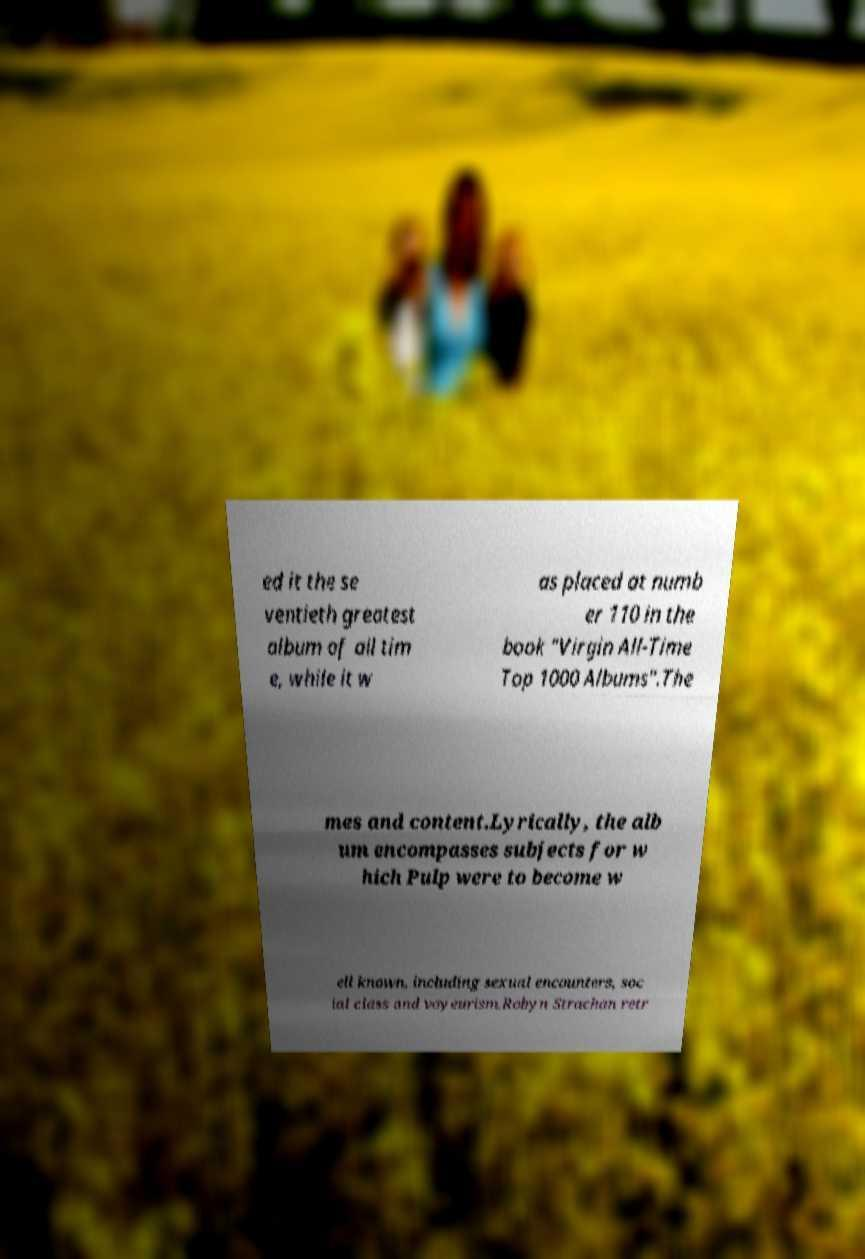What messages or text are displayed in this image? I need them in a readable, typed format. ed it the se ventieth greatest album of all tim e, while it w as placed at numb er 110 in the book "Virgin All-Time Top 1000 Albums".The mes and content.Lyrically, the alb um encompasses subjects for w hich Pulp were to become w ell known, including sexual encounters, soc ial class and voyeurism.Robyn Strachan retr 